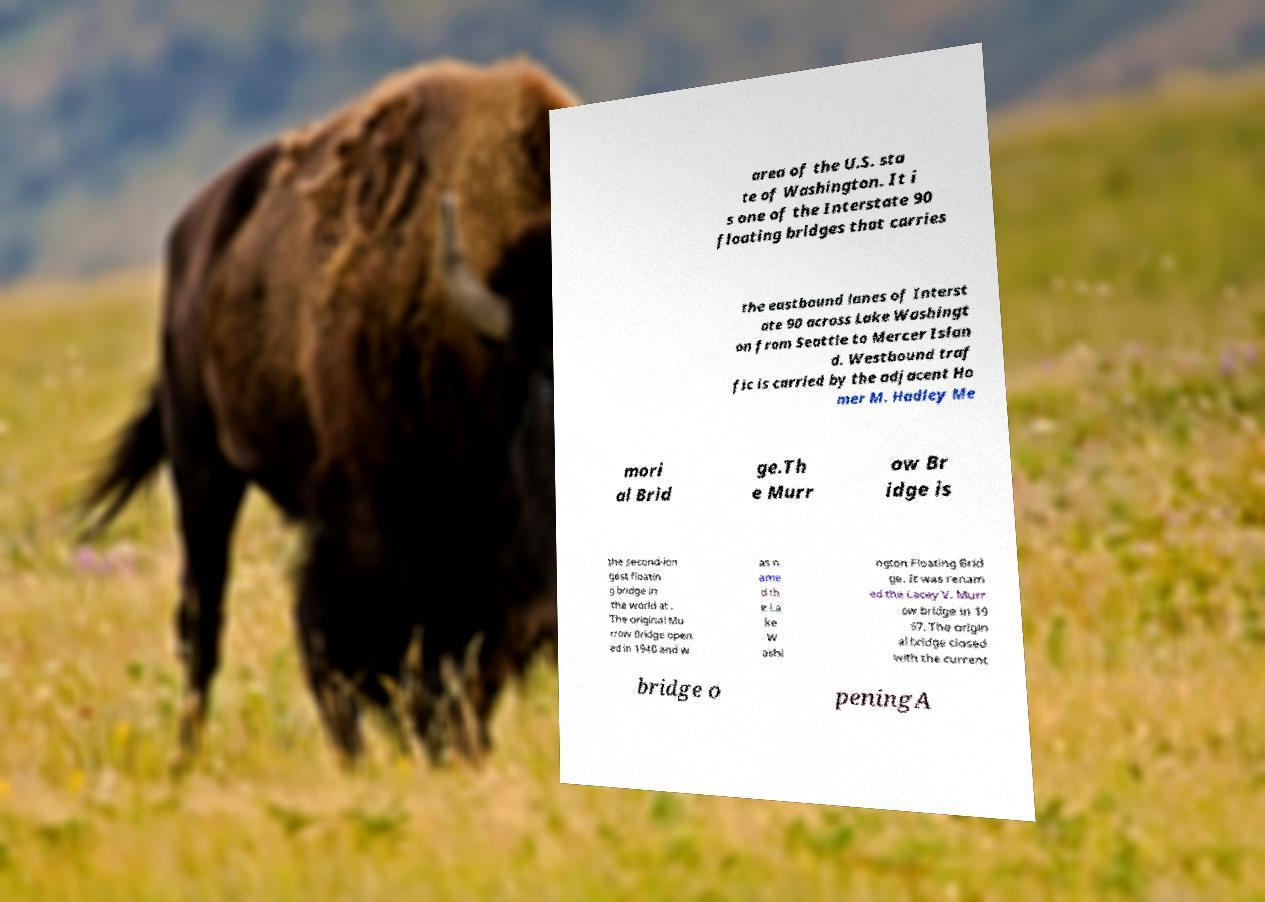What messages or text are displayed in this image? I need them in a readable, typed format. area of the U.S. sta te of Washington. It i s one of the Interstate 90 floating bridges that carries the eastbound lanes of Interst ate 90 across Lake Washingt on from Seattle to Mercer Islan d. Westbound traf fic is carried by the adjacent Ho mer M. Hadley Me mori al Brid ge.Th e Murr ow Br idge is the second-lon gest floatin g bridge in the world at . The original Mu rrow Bridge open ed in 1940 and w as n ame d th e La ke W ashi ngton Floating Brid ge. It was renam ed the Lacey V. Murr ow bridge in 19 67. The origin al bridge closed with the current bridge o peningA 